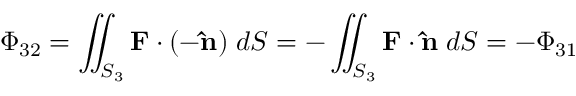<formula> <loc_0><loc_0><loc_500><loc_500>\Phi _ { 3 2 } = \iint _ { S _ { 3 } } F \cdot ( - \hat { n } ) \, d S = - \iint _ { S _ { 3 } } F \cdot \hat { n } \, d S = - \Phi _ { 3 1 }</formula> 